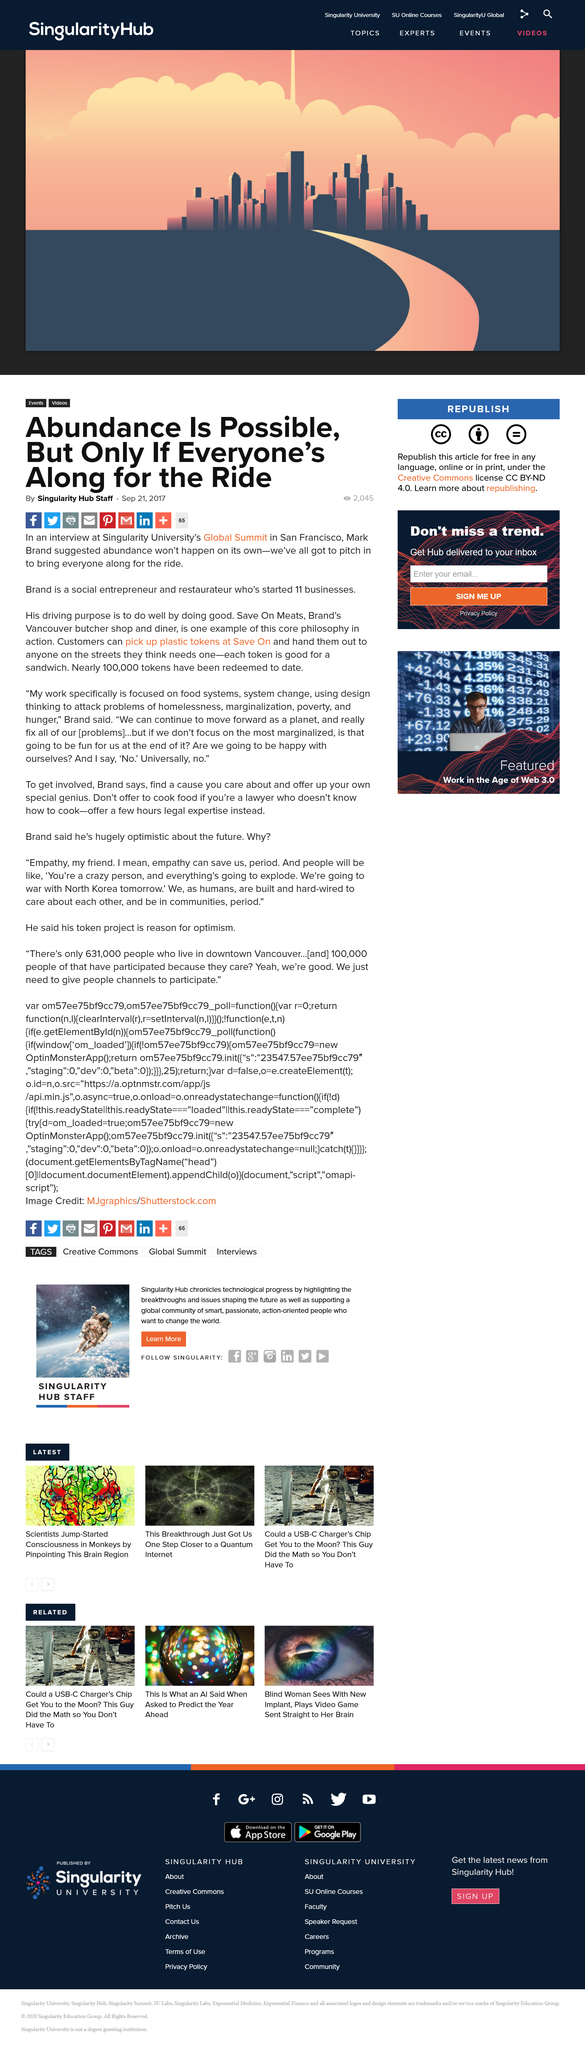List a handful of essential elements in this visual. As of now, nearly 100,000 tokens have been redeemed. A plastic token used at Save On Meats can be utilized for redeeming a sandwich. Mark Brand is a social entrepreneur and restaurateur who is known for his contributions to the food and beverage industry. 